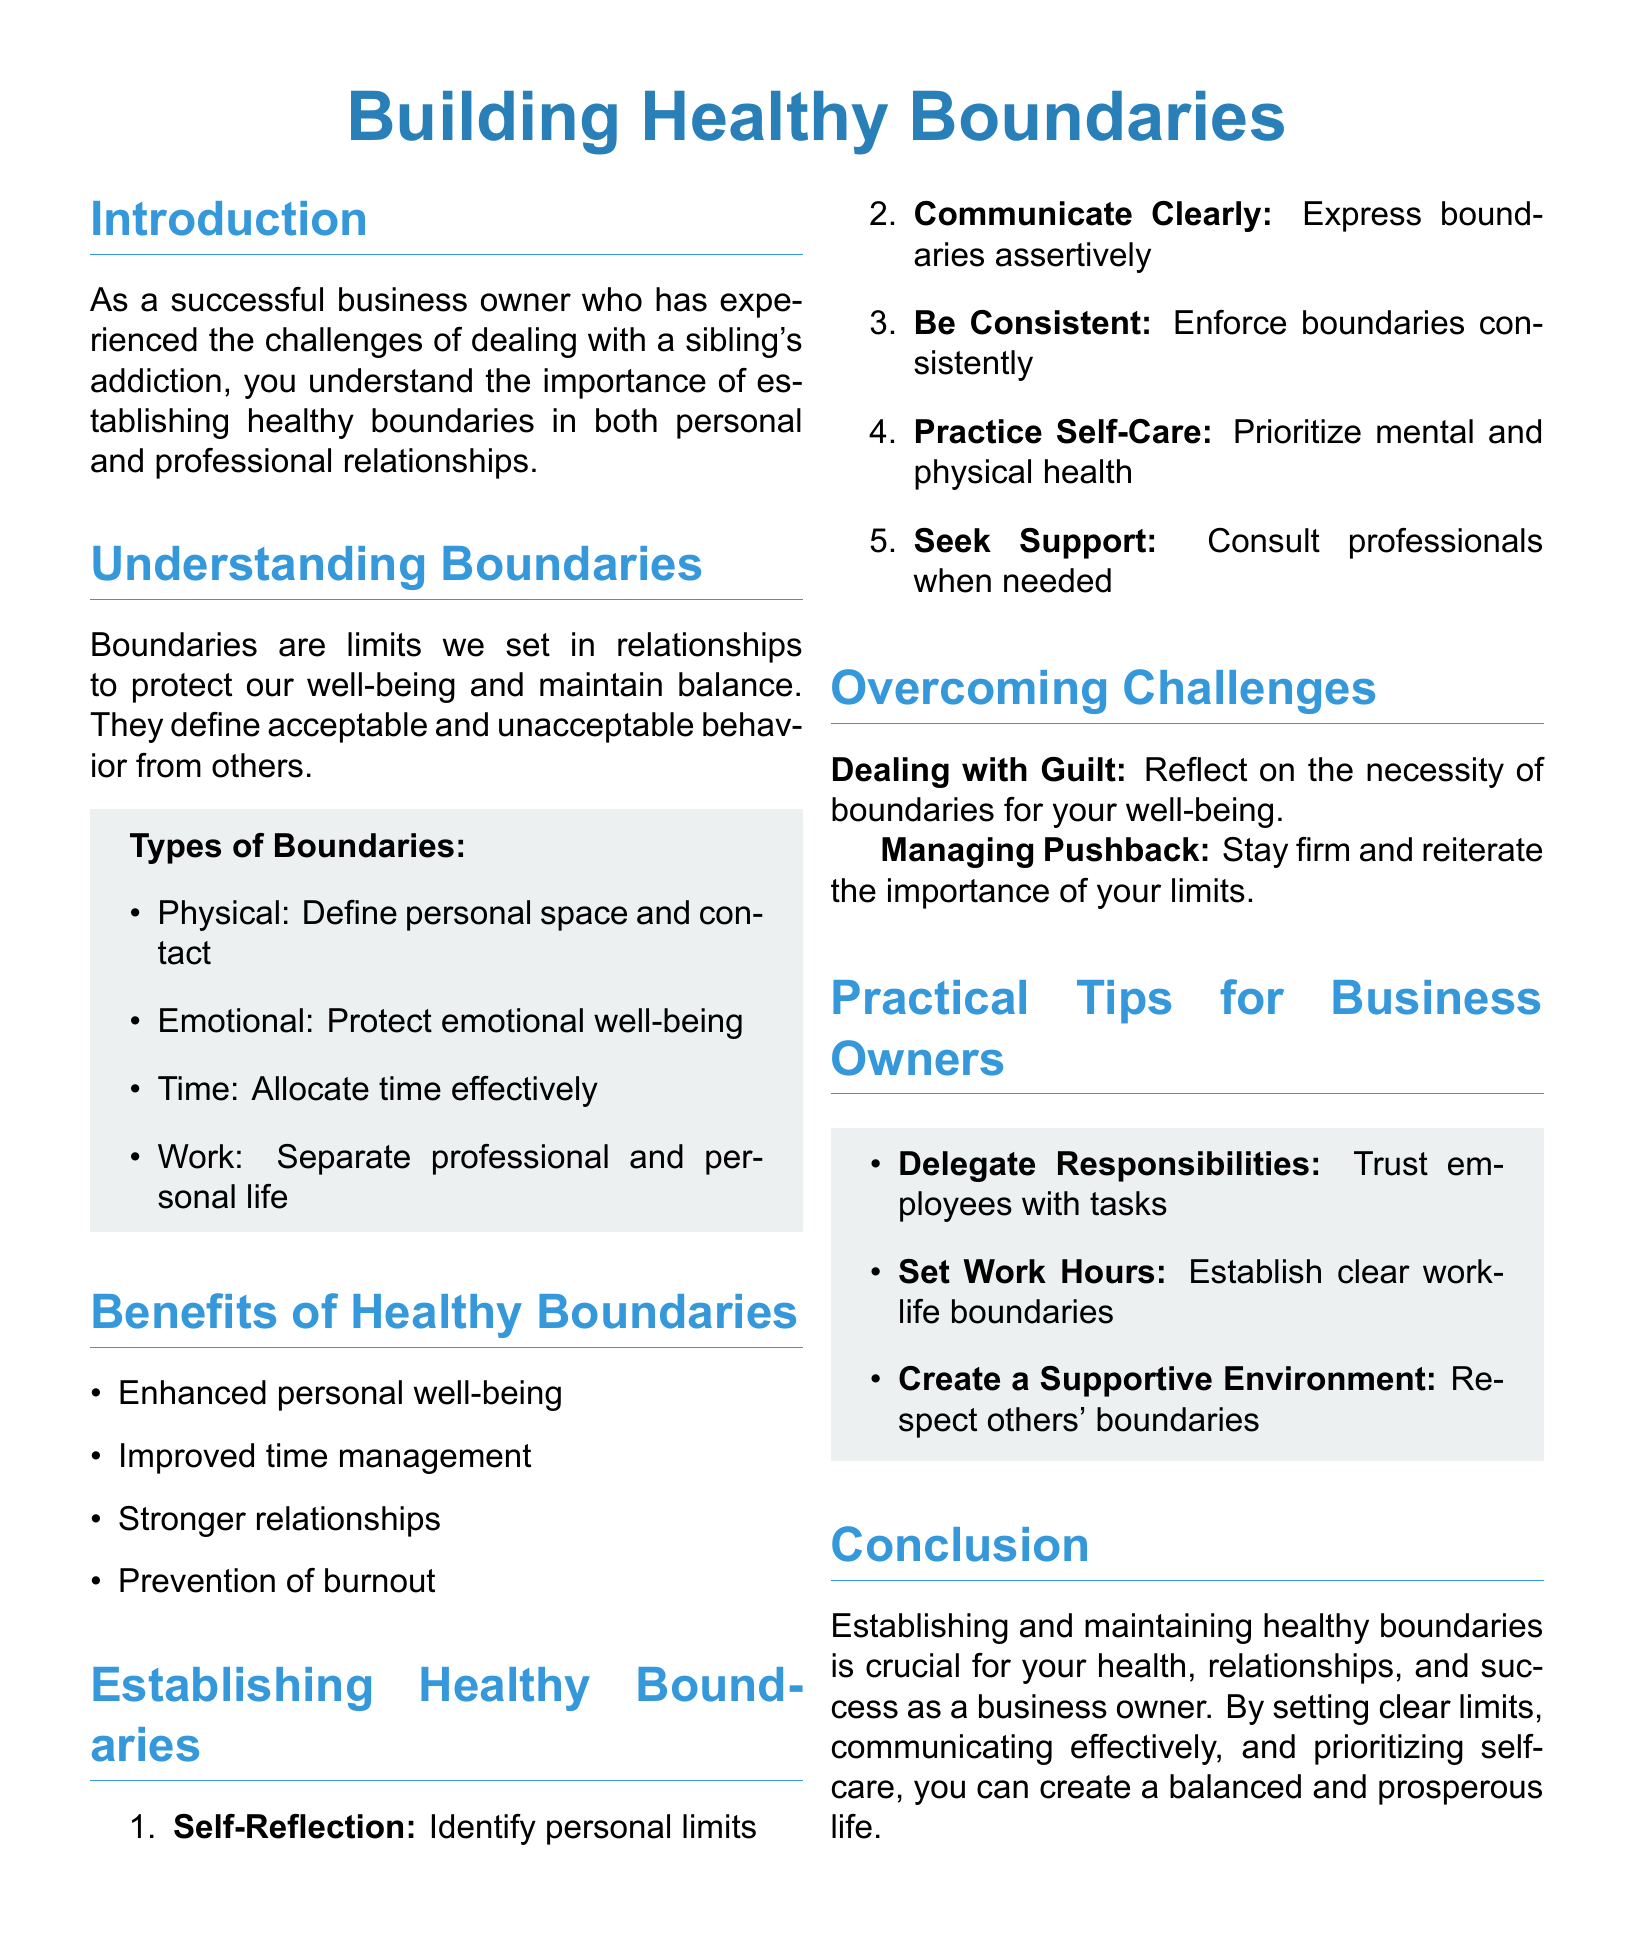What are the four types of boundaries? The document lists four types of boundaries: Physical, Emotional, Time, and Work.
Answer: Physical, Emotional, Time, Work What is the first step in establishing healthy boundaries? The first step in establishing healthy boundaries according to the document is self-reflection.
Answer: Self-Reflection What are two benefits of having healthy boundaries? The document mentions improved time management and enhanced personal well-being as benefits of healthy boundaries.
Answer: Improved time management, enhanced personal well-being What should you prioritize for your health according to the guide? The guide emphasizes the importance of self-care for mental and physical health.
Answer: Self-Care How many points are there in the "Establishing Healthy Boundaries" section? The document includes five points in the "Establishing Healthy Boundaries" section.
Answer: Five What is suggested to help with managing pushback? The recommended action for managing pushback is to stay firm and reiterate the importance of your limits.
Answer: Stay firm What color is used for titles in the document? The document uses a title color defined by the RGB values (41,128,185) for titles.
Answer: RGB (41,128,185) What is a practical tip for business owners from the guide? The guide suggests delegating responsibilities as a practical tip for business owners.
Answer: Delegate Responsibilities 